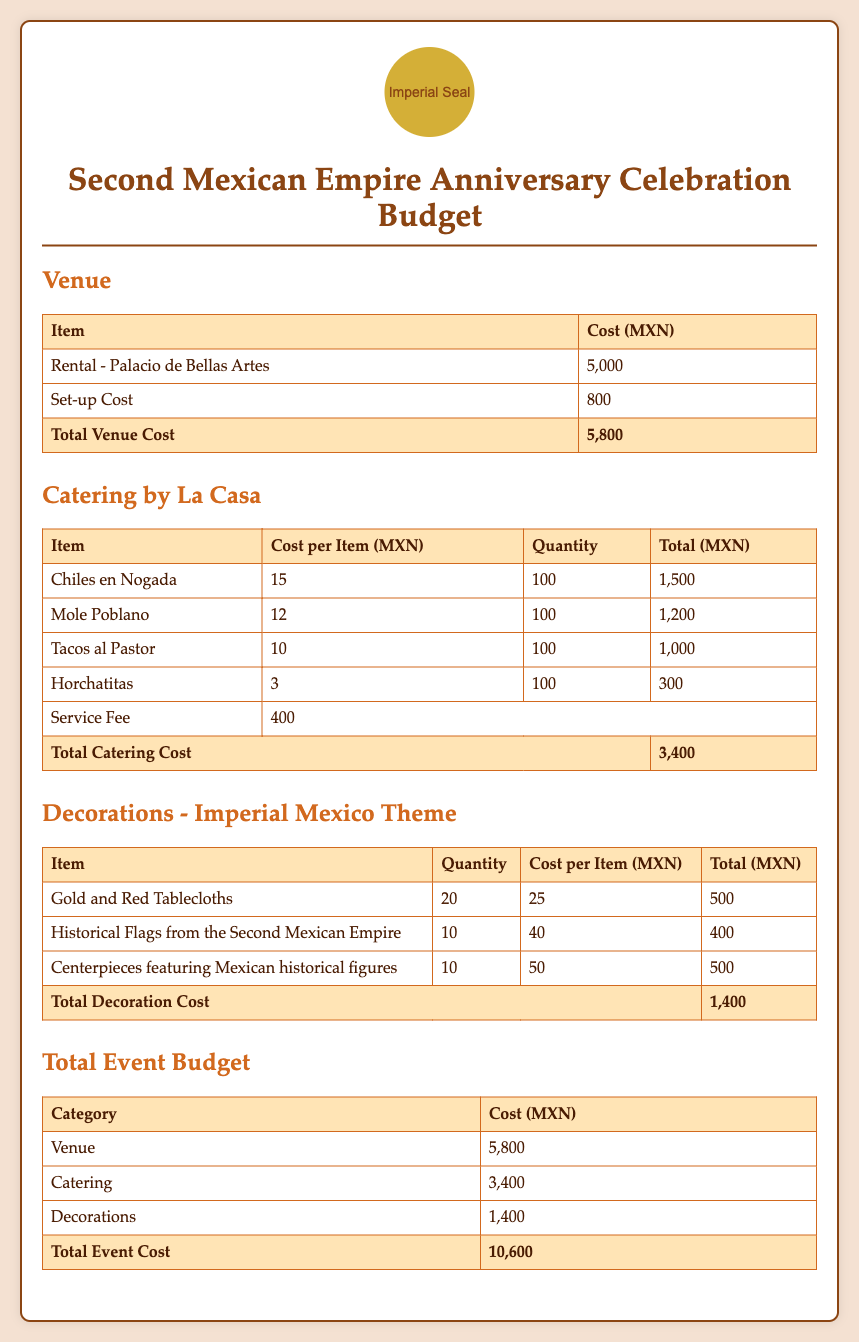What is the total venue cost? The total venue cost is the sum of the rental and set-up costs for the venue, which is 5000 + 800.
Answer: 5800 How many chiles en nogada will be served? The document states that 100 chiles en nogada will be served, as indicated in the catering section.
Answer: 100 What is the cost of the service fee for catering? The catering section specifies that the service fee is 400 MXN.
Answer: 400 What is the total decoration cost? The total decoration cost is provided after listing the individual decoration items, which sums up to 1400 MXN.
Answer: 1400 What is the cost of renting the Palacio de Bellas Artes? The document indicates that the rental cost for Palacio de Bellas Artes is 5000 MXN.
Answer: 5000 How many items are listed under catering? There are four distinct food items listed under the catering section, including chiles en nogada, mole poblano, tacos al pastor, and horchatitas.
Answer: 4 What are the total estimated costs for the entire event? The total event cost is calculated by adding venue, catering, and decoration costs, which equals 10600 MXN.
Answer: 10600 How many historical flags from the Second Mexican Empire are planned for decorations? According to the decorations section, there are 10 historical flags planned.
Answer: 10 What is the cost per item for mole poblano? The document states that the cost per item for mole poblano is 12 MXN.
Answer: 12 